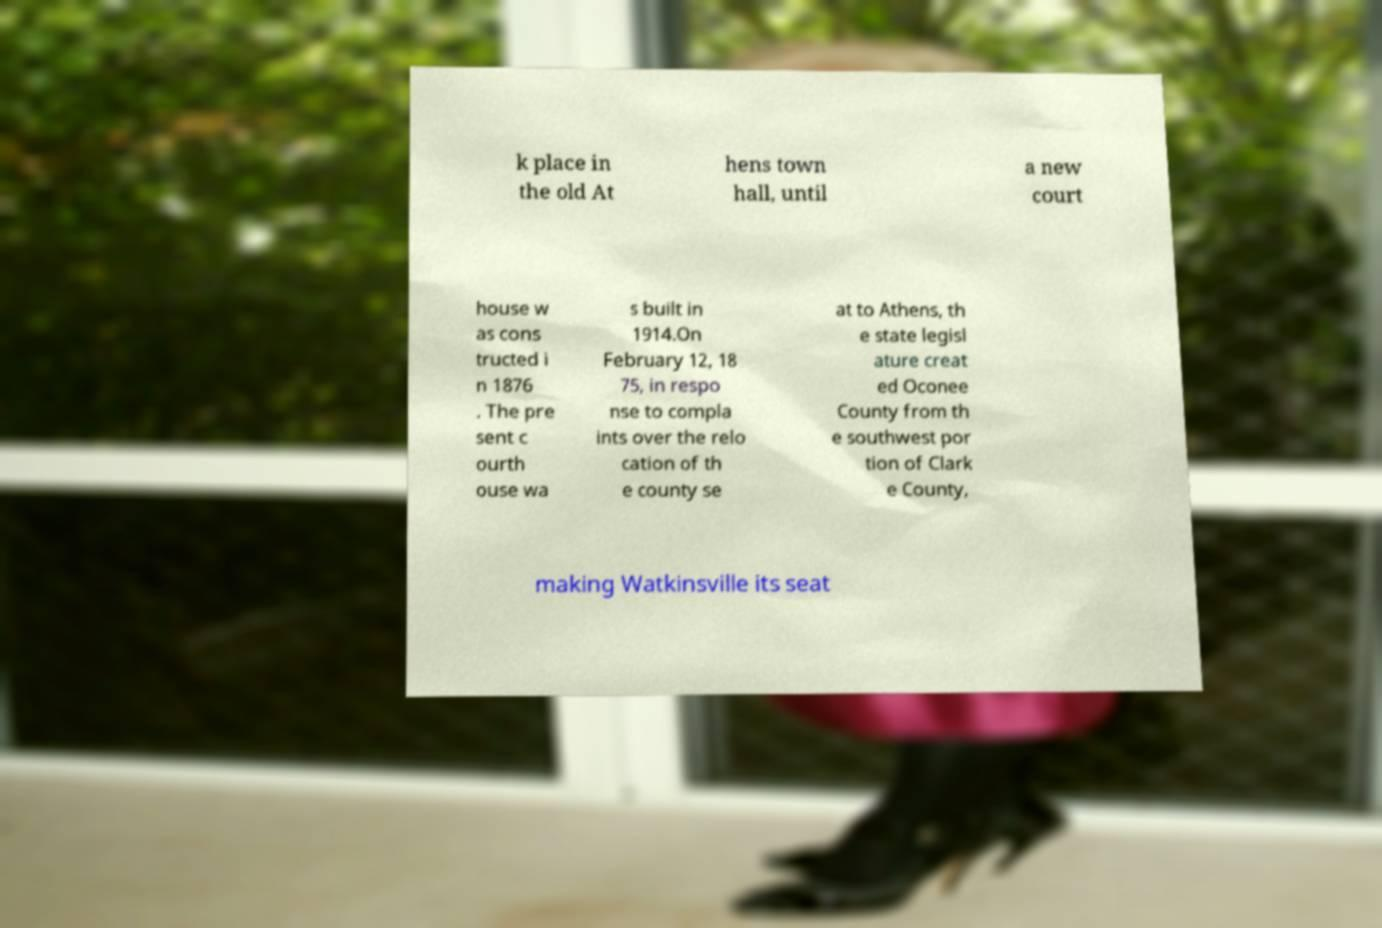Please read and relay the text visible in this image. What does it say? k place in the old At hens town hall, until a new court house w as cons tructed i n 1876 . The pre sent c ourth ouse wa s built in 1914.On February 12, 18 75, in respo nse to compla ints over the relo cation of th e county se at to Athens, th e state legisl ature creat ed Oconee County from th e southwest por tion of Clark e County, making Watkinsville its seat 